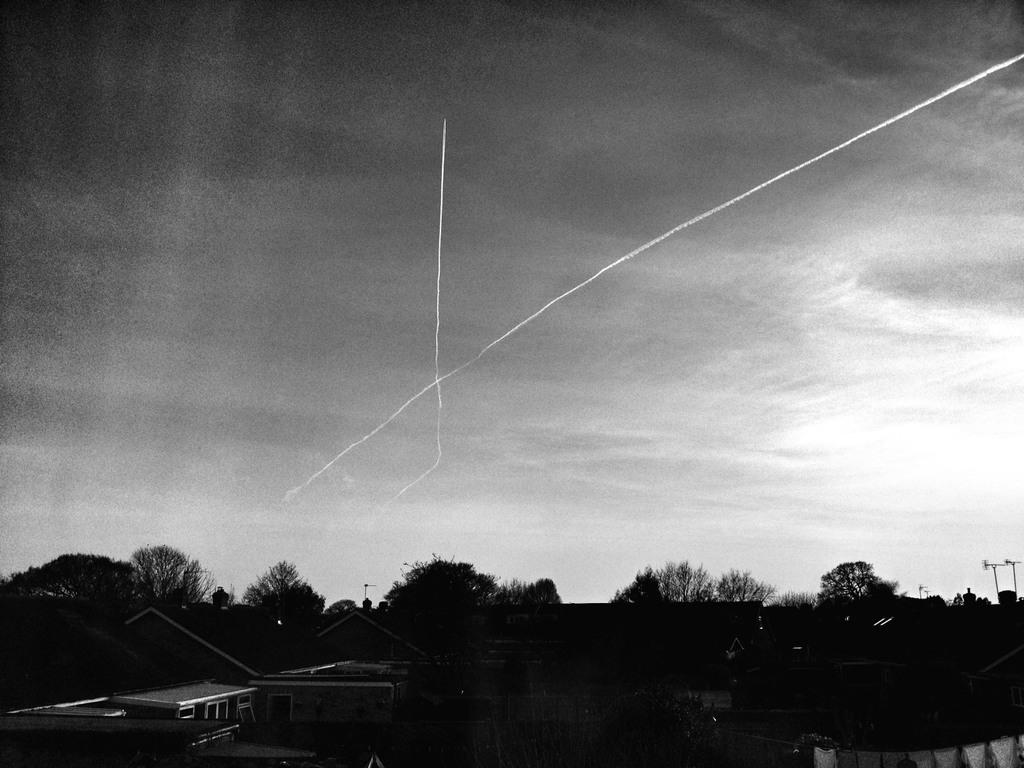What type of natural elements can be seen in the image? There are many trees in the image. What type of man-made structures are present in the image? There are buildings in the image. What is visible at the top of the image? The sky is visible at the top of the image. What can be seen in the sky in the image? Clouds are present in the sky. What type of design can be seen on the train in the image? There is no train present in the image; it features trees, buildings, and clouds in the sky. Who is the guide in the image? There is no guide present in the image. 